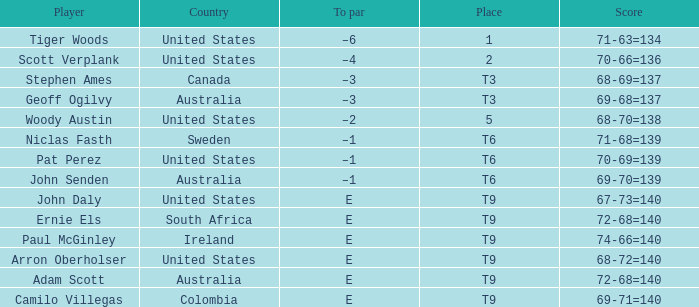Which player is from Sweden? Niclas Fasth. 